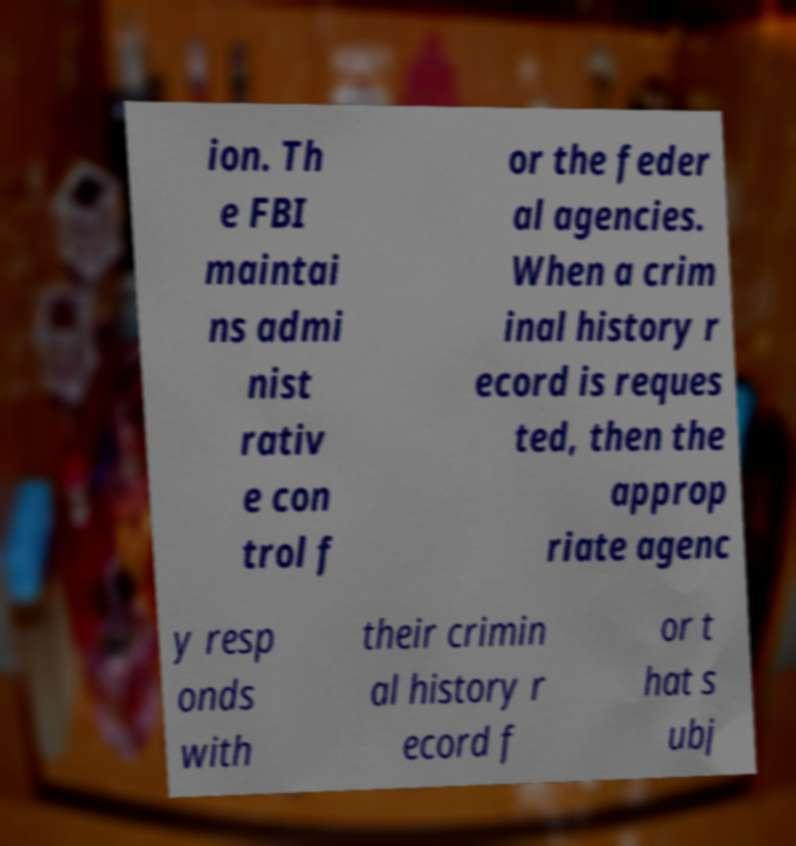For documentation purposes, I need the text within this image transcribed. Could you provide that? ion. Th e FBI maintai ns admi nist rativ e con trol f or the feder al agencies. When a crim inal history r ecord is reques ted, then the approp riate agenc y resp onds with their crimin al history r ecord f or t hat s ubj 